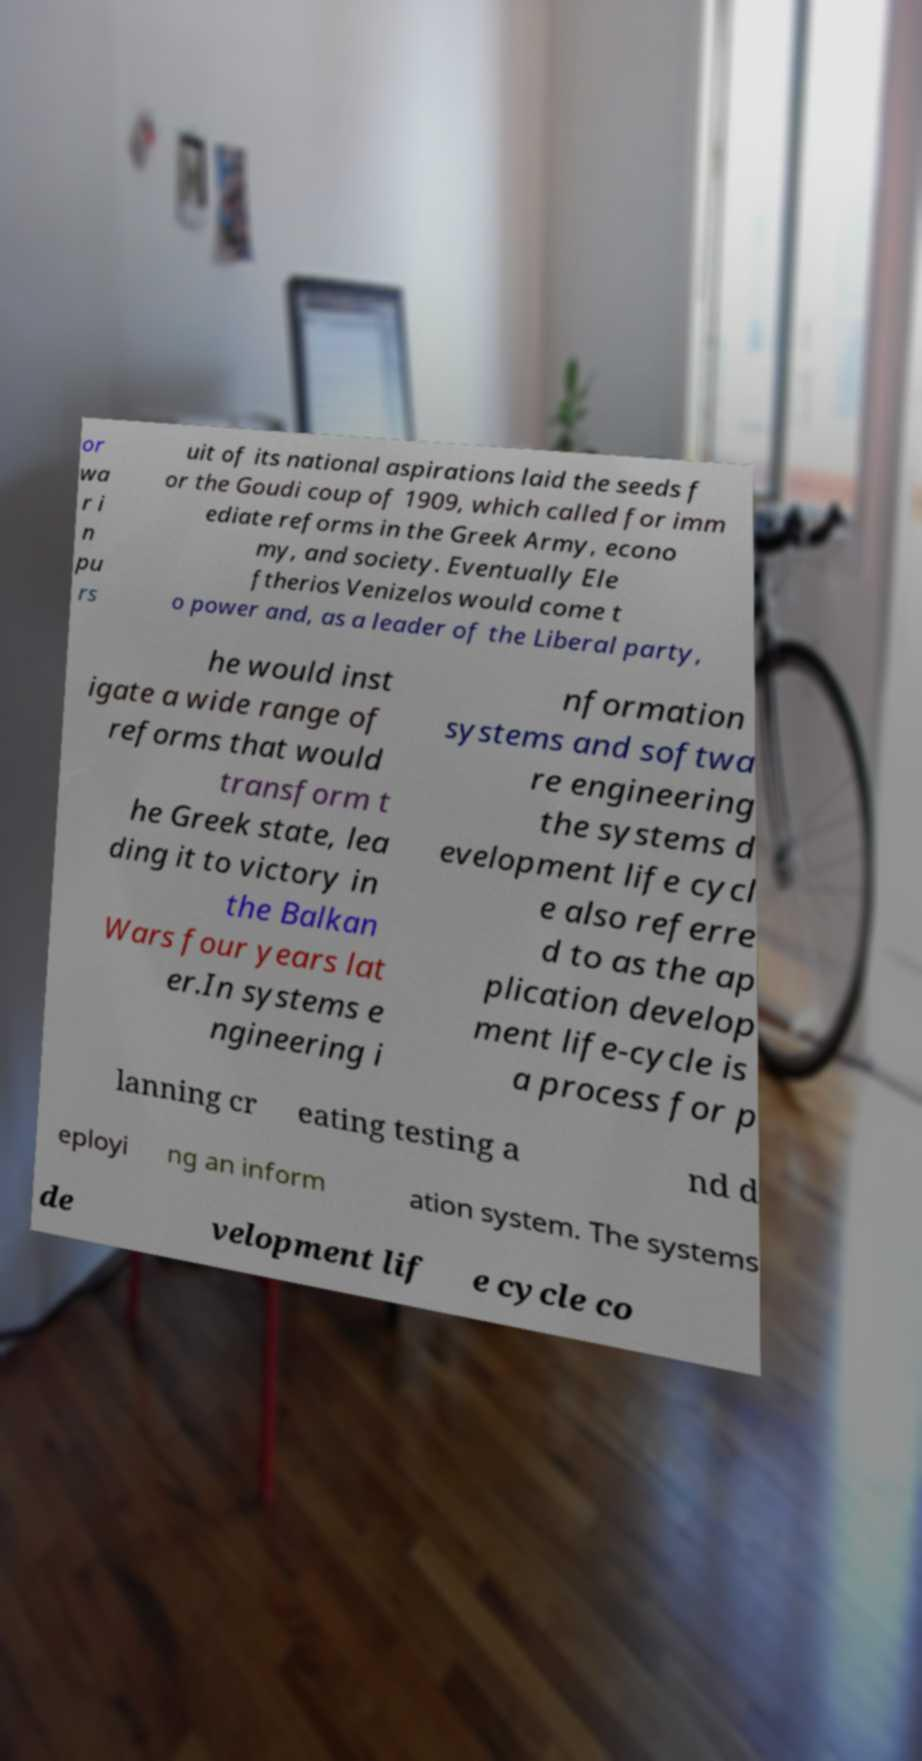What messages or text are displayed in this image? I need them in a readable, typed format. or wa r i n pu rs uit of its national aspirations laid the seeds f or the Goudi coup of 1909, which called for imm ediate reforms in the Greek Army, econo my, and society. Eventually Ele ftherios Venizelos would come t o power and, as a leader of the Liberal party, he would inst igate a wide range of reforms that would transform t he Greek state, lea ding it to victory in the Balkan Wars four years lat er.In systems e ngineering i nformation systems and softwa re engineering the systems d evelopment life cycl e also referre d to as the ap plication develop ment life-cycle is a process for p lanning cr eating testing a nd d eployi ng an inform ation system. The systems de velopment lif e cycle co 